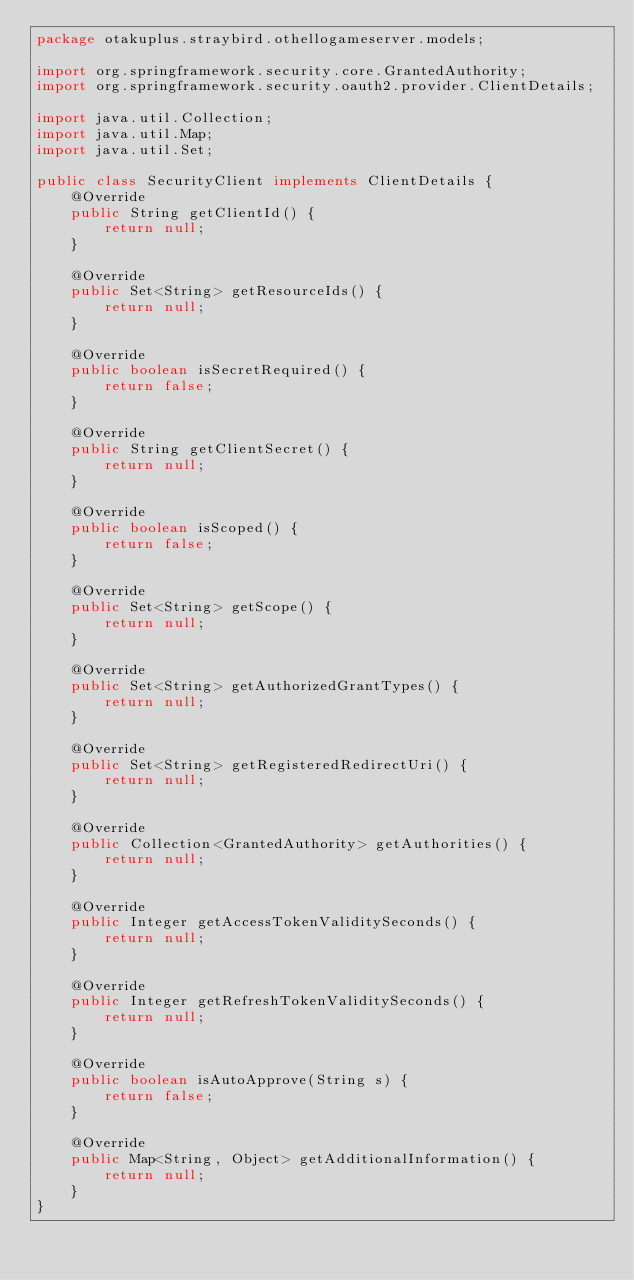Convert code to text. <code><loc_0><loc_0><loc_500><loc_500><_Java_>package otakuplus.straybird.othellogameserver.models;

import org.springframework.security.core.GrantedAuthority;
import org.springframework.security.oauth2.provider.ClientDetails;

import java.util.Collection;
import java.util.Map;
import java.util.Set;

public class SecurityClient implements ClientDetails {
    @Override
    public String getClientId() {
        return null;
    }

    @Override
    public Set<String> getResourceIds() {
        return null;
    }

    @Override
    public boolean isSecretRequired() {
        return false;
    }

    @Override
    public String getClientSecret() {
        return null;
    }

    @Override
    public boolean isScoped() {
        return false;
    }

    @Override
    public Set<String> getScope() {
        return null;
    }

    @Override
    public Set<String> getAuthorizedGrantTypes() {
        return null;
    }

    @Override
    public Set<String> getRegisteredRedirectUri() {
        return null;
    }

    @Override
    public Collection<GrantedAuthority> getAuthorities() {
        return null;
    }

    @Override
    public Integer getAccessTokenValiditySeconds() {
        return null;
    }

    @Override
    public Integer getRefreshTokenValiditySeconds() {
        return null;
    }

    @Override
    public boolean isAutoApprove(String s) {
        return false;
    }

    @Override
    public Map<String, Object> getAdditionalInformation() {
        return null;
    }
}
</code> 